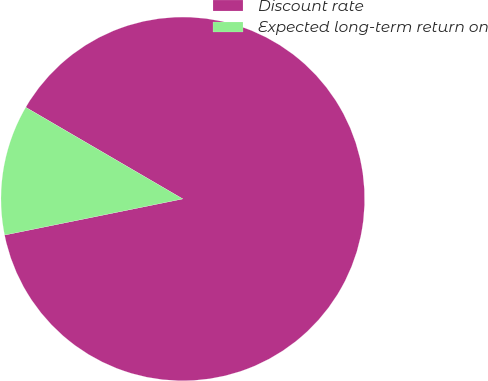Convert chart. <chart><loc_0><loc_0><loc_500><loc_500><pie_chart><fcel>Discount rate<fcel>Expected long-term return on<nl><fcel>88.41%<fcel>11.59%<nl></chart> 